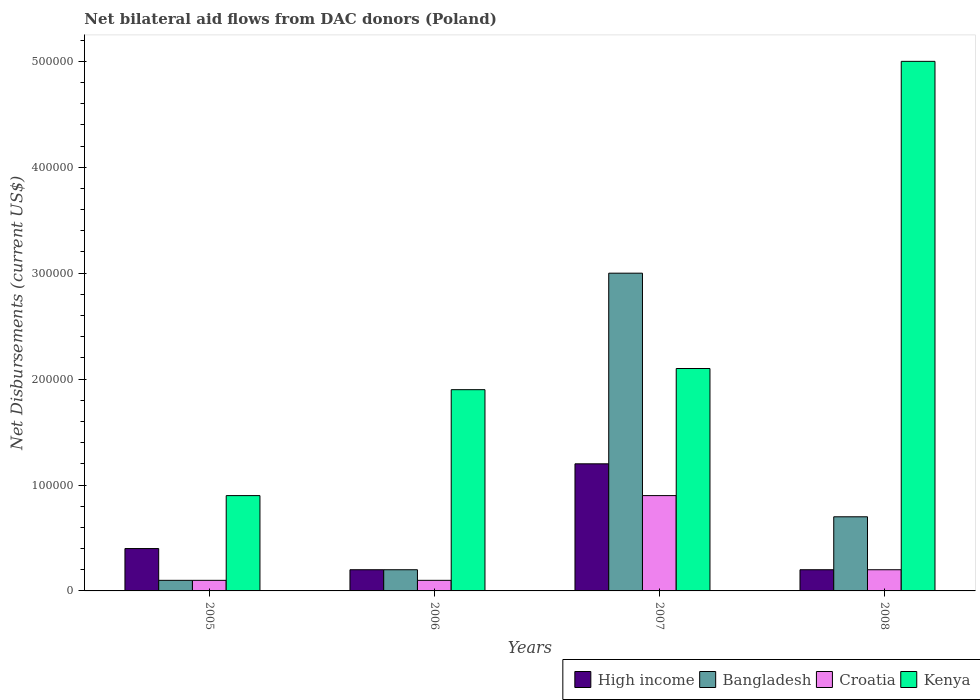How many different coloured bars are there?
Your answer should be compact. 4. How many groups of bars are there?
Your answer should be compact. 4. Are the number of bars on each tick of the X-axis equal?
Provide a short and direct response. Yes. How many bars are there on the 4th tick from the left?
Give a very brief answer. 4. How many bars are there on the 2nd tick from the right?
Make the answer very short. 4. What is the net bilateral aid flows in Croatia in 2008?
Provide a short and direct response. 2.00e+04. Across all years, what is the maximum net bilateral aid flows in Bangladesh?
Provide a short and direct response. 3.00e+05. Across all years, what is the minimum net bilateral aid flows in Bangladesh?
Provide a succinct answer. 10000. What is the total net bilateral aid flows in Bangladesh in the graph?
Your response must be concise. 4.00e+05. What is the difference between the net bilateral aid flows in High income in 2005 and that in 2008?
Provide a short and direct response. 2.00e+04. What is the average net bilateral aid flows in Croatia per year?
Ensure brevity in your answer.  3.25e+04. In the year 2006, what is the difference between the net bilateral aid flows in Kenya and net bilateral aid flows in Croatia?
Offer a terse response. 1.80e+05. What is the ratio of the net bilateral aid flows in Kenya in 2005 to that in 2008?
Offer a terse response. 0.18. What is the difference between the highest and the second highest net bilateral aid flows in High income?
Provide a short and direct response. 8.00e+04. In how many years, is the net bilateral aid flows in Croatia greater than the average net bilateral aid flows in Croatia taken over all years?
Give a very brief answer. 1. Is the sum of the net bilateral aid flows in Croatia in 2006 and 2007 greater than the maximum net bilateral aid flows in Kenya across all years?
Give a very brief answer. No. What does the 2nd bar from the left in 2005 represents?
Ensure brevity in your answer.  Bangladesh. Are all the bars in the graph horizontal?
Give a very brief answer. No. Are the values on the major ticks of Y-axis written in scientific E-notation?
Offer a very short reply. No. How are the legend labels stacked?
Ensure brevity in your answer.  Horizontal. What is the title of the graph?
Provide a succinct answer. Net bilateral aid flows from DAC donors (Poland). What is the label or title of the Y-axis?
Make the answer very short. Net Disbursements (current US$). What is the Net Disbursements (current US$) of Croatia in 2005?
Offer a very short reply. 10000. What is the Net Disbursements (current US$) of Kenya in 2005?
Make the answer very short. 9.00e+04. What is the Net Disbursements (current US$) of Croatia in 2007?
Make the answer very short. 9.00e+04. What is the Net Disbursements (current US$) of Kenya in 2008?
Ensure brevity in your answer.  5.00e+05. Across all years, what is the maximum Net Disbursements (current US$) in High income?
Your answer should be compact. 1.20e+05. Across all years, what is the maximum Net Disbursements (current US$) in Croatia?
Your answer should be very brief. 9.00e+04. Across all years, what is the maximum Net Disbursements (current US$) in Kenya?
Offer a terse response. 5.00e+05. Across all years, what is the minimum Net Disbursements (current US$) in Bangladesh?
Your response must be concise. 10000. Across all years, what is the minimum Net Disbursements (current US$) of Kenya?
Your answer should be very brief. 9.00e+04. What is the total Net Disbursements (current US$) of High income in the graph?
Your answer should be compact. 2.00e+05. What is the total Net Disbursements (current US$) in Kenya in the graph?
Your answer should be very brief. 9.90e+05. What is the difference between the Net Disbursements (current US$) in Bangladesh in 2005 and that in 2006?
Give a very brief answer. -10000. What is the difference between the Net Disbursements (current US$) of Croatia in 2005 and that in 2006?
Keep it short and to the point. 0. What is the difference between the Net Disbursements (current US$) of Kenya in 2005 and that in 2006?
Your response must be concise. -1.00e+05. What is the difference between the Net Disbursements (current US$) of Croatia in 2005 and that in 2007?
Ensure brevity in your answer.  -8.00e+04. What is the difference between the Net Disbursements (current US$) of Bangladesh in 2005 and that in 2008?
Keep it short and to the point. -6.00e+04. What is the difference between the Net Disbursements (current US$) of Kenya in 2005 and that in 2008?
Your answer should be very brief. -4.10e+05. What is the difference between the Net Disbursements (current US$) of Bangladesh in 2006 and that in 2007?
Give a very brief answer. -2.80e+05. What is the difference between the Net Disbursements (current US$) in Croatia in 2006 and that in 2007?
Ensure brevity in your answer.  -8.00e+04. What is the difference between the Net Disbursements (current US$) of Kenya in 2006 and that in 2007?
Keep it short and to the point. -2.00e+04. What is the difference between the Net Disbursements (current US$) of Bangladesh in 2006 and that in 2008?
Give a very brief answer. -5.00e+04. What is the difference between the Net Disbursements (current US$) in Croatia in 2006 and that in 2008?
Provide a succinct answer. -10000. What is the difference between the Net Disbursements (current US$) in Kenya in 2006 and that in 2008?
Ensure brevity in your answer.  -3.10e+05. What is the difference between the Net Disbursements (current US$) in Bangladesh in 2007 and that in 2008?
Your response must be concise. 2.30e+05. What is the difference between the Net Disbursements (current US$) in Croatia in 2007 and that in 2008?
Make the answer very short. 7.00e+04. What is the difference between the Net Disbursements (current US$) of Kenya in 2007 and that in 2008?
Your response must be concise. -2.90e+05. What is the difference between the Net Disbursements (current US$) in High income in 2005 and the Net Disbursements (current US$) in Bangladesh in 2006?
Your response must be concise. 2.00e+04. What is the difference between the Net Disbursements (current US$) of High income in 2005 and the Net Disbursements (current US$) of Croatia in 2006?
Provide a short and direct response. 3.00e+04. What is the difference between the Net Disbursements (current US$) in High income in 2005 and the Net Disbursements (current US$) in Kenya in 2006?
Keep it short and to the point. -1.50e+05. What is the difference between the Net Disbursements (current US$) of Croatia in 2005 and the Net Disbursements (current US$) of Kenya in 2006?
Offer a very short reply. -1.80e+05. What is the difference between the Net Disbursements (current US$) of High income in 2005 and the Net Disbursements (current US$) of Croatia in 2007?
Your response must be concise. -5.00e+04. What is the difference between the Net Disbursements (current US$) of High income in 2005 and the Net Disbursements (current US$) of Kenya in 2007?
Provide a succinct answer. -1.70e+05. What is the difference between the Net Disbursements (current US$) of Bangladesh in 2005 and the Net Disbursements (current US$) of Croatia in 2007?
Provide a succinct answer. -8.00e+04. What is the difference between the Net Disbursements (current US$) of Bangladesh in 2005 and the Net Disbursements (current US$) of Kenya in 2007?
Make the answer very short. -2.00e+05. What is the difference between the Net Disbursements (current US$) of High income in 2005 and the Net Disbursements (current US$) of Bangladesh in 2008?
Provide a short and direct response. -3.00e+04. What is the difference between the Net Disbursements (current US$) in High income in 2005 and the Net Disbursements (current US$) in Kenya in 2008?
Provide a succinct answer. -4.60e+05. What is the difference between the Net Disbursements (current US$) of Bangladesh in 2005 and the Net Disbursements (current US$) of Kenya in 2008?
Offer a terse response. -4.90e+05. What is the difference between the Net Disbursements (current US$) in Croatia in 2005 and the Net Disbursements (current US$) in Kenya in 2008?
Ensure brevity in your answer.  -4.90e+05. What is the difference between the Net Disbursements (current US$) in High income in 2006 and the Net Disbursements (current US$) in Bangladesh in 2007?
Your answer should be very brief. -2.80e+05. What is the difference between the Net Disbursements (current US$) of High income in 2006 and the Net Disbursements (current US$) of Croatia in 2007?
Provide a succinct answer. -7.00e+04. What is the difference between the Net Disbursements (current US$) of Croatia in 2006 and the Net Disbursements (current US$) of Kenya in 2007?
Ensure brevity in your answer.  -2.00e+05. What is the difference between the Net Disbursements (current US$) in High income in 2006 and the Net Disbursements (current US$) in Bangladesh in 2008?
Provide a short and direct response. -5.00e+04. What is the difference between the Net Disbursements (current US$) in High income in 2006 and the Net Disbursements (current US$) in Croatia in 2008?
Offer a very short reply. 0. What is the difference between the Net Disbursements (current US$) in High income in 2006 and the Net Disbursements (current US$) in Kenya in 2008?
Provide a short and direct response. -4.80e+05. What is the difference between the Net Disbursements (current US$) in Bangladesh in 2006 and the Net Disbursements (current US$) in Kenya in 2008?
Give a very brief answer. -4.80e+05. What is the difference between the Net Disbursements (current US$) of Croatia in 2006 and the Net Disbursements (current US$) of Kenya in 2008?
Keep it short and to the point. -4.90e+05. What is the difference between the Net Disbursements (current US$) of High income in 2007 and the Net Disbursements (current US$) of Bangladesh in 2008?
Give a very brief answer. 5.00e+04. What is the difference between the Net Disbursements (current US$) of High income in 2007 and the Net Disbursements (current US$) of Kenya in 2008?
Make the answer very short. -3.80e+05. What is the difference between the Net Disbursements (current US$) of Bangladesh in 2007 and the Net Disbursements (current US$) of Croatia in 2008?
Provide a succinct answer. 2.80e+05. What is the difference between the Net Disbursements (current US$) in Bangladesh in 2007 and the Net Disbursements (current US$) in Kenya in 2008?
Provide a short and direct response. -2.00e+05. What is the difference between the Net Disbursements (current US$) of Croatia in 2007 and the Net Disbursements (current US$) of Kenya in 2008?
Your answer should be very brief. -4.10e+05. What is the average Net Disbursements (current US$) in High income per year?
Offer a very short reply. 5.00e+04. What is the average Net Disbursements (current US$) of Croatia per year?
Your response must be concise. 3.25e+04. What is the average Net Disbursements (current US$) of Kenya per year?
Your answer should be very brief. 2.48e+05. In the year 2005, what is the difference between the Net Disbursements (current US$) of High income and Net Disbursements (current US$) of Bangladesh?
Make the answer very short. 3.00e+04. In the year 2005, what is the difference between the Net Disbursements (current US$) in High income and Net Disbursements (current US$) in Croatia?
Offer a very short reply. 3.00e+04. In the year 2005, what is the difference between the Net Disbursements (current US$) in Bangladesh and Net Disbursements (current US$) in Kenya?
Ensure brevity in your answer.  -8.00e+04. In the year 2005, what is the difference between the Net Disbursements (current US$) in Croatia and Net Disbursements (current US$) in Kenya?
Make the answer very short. -8.00e+04. In the year 2006, what is the difference between the Net Disbursements (current US$) of High income and Net Disbursements (current US$) of Bangladesh?
Provide a short and direct response. 0. In the year 2006, what is the difference between the Net Disbursements (current US$) in High income and Net Disbursements (current US$) in Croatia?
Provide a succinct answer. 10000. In the year 2006, what is the difference between the Net Disbursements (current US$) of High income and Net Disbursements (current US$) of Kenya?
Give a very brief answer. -1.70e+05. In the year 2006, what is the difference between the Net Disbursements (current US$) of Bangladesh and Net Disbursements (current US$) of Croatia?
Provide a short and direct response. 10000. In the year 2006, what is the difference between the Net Disbursements (current US$) in Bangladesh and Net Disbursements (current US$) in Kenya?
Offer a terse response. -1.70e+05. In the year 2007, what is the difference between the Net Disbursements (current US$) in High income and Net Disbursements (current US$) in Bangladesh?
Your response must be concise. -1.80e+05. In the year 2007, what is the difference between the Net Disbursements (current US$) in High income and Net Disbursements (current US$) in Kenya?
Your answer should be very brief. -9.00e+04. In the year 2007, what is the difference between the Net Disbursements (current US$) of Bangladesh and Net Disbursements (current US$) of Kenya?
Provide a short and direct response. 9.00e+04. In the year 2007, what is the difference between the Net Disbursements (current US$) in Croatia and Net Disbursements (current US$) in Kenya?
Make the answer very short. -1.20e+05. In the year 2008, what is the difference between the Net Disbursements (current US$) in High income and Net Disbursements (current US$) in Kenya?
Your answer should be very brief. -4.80e+05. In the year 2008, what is the difference between the Net Disbursements (current US$) in Bangladesh and Net Disbursements (current US$) in Kenya?
Give a very brief answer. -4.30e+05. In the year 2008, what is the difference between the Net Disbursements (current US$) of Croatia and Net Disbursements (current US$) of Kenya?
Ensure brevity in your answer.  -4.80e+05. What is the ratio of the Net Disbursements (current US$) in High income in 2005 to that in 2006?
Provide a succinct answer. 2. What is the ratio of the Net Disbursements (current US$) of Bangladesh in 2005 to that in 2006?
Give a very brief answer. 0.5. What is the ratio of the Net Disbursements (current US$) of Croatia in 2005 to that in 2006?
Offer a terse response. 1. What is the ratio of the Net Disbursements (current US$) in Kenya in 2005 to that in 2006?
Provide a succinct answer. 0.47. What is the ratio of the Net Disbursements (current US$) of High income in 2005 to that in 2007?
Keep it short and to the point. 0.33. What is the ratio of the Net Disbursements (current US$) of Bangladesh in 2005 to that in 2007?
Make the answer very short. 0.03. What is the ratio of the Net Disbursements (current US$) of Kenya in 2005 to that in 2007?
Your answer should be very brief. 0.43. What is the ratio of the Net Disbursements (current US$) of Bangladesh in 2005 to that in 2008?
Keep it short and to the point. 0.14. What is the ratio of the Net Disbursements (current US$) of Kenya in 2005 to that in 2008?
Offer a very short reply. 0.18. What is the ratio of the Net Disbursements (current US$) in Bangladesh in 2006 to that in 2007?
Give a very brief answer. 0.07. What is the ratio of the Net Disbursements (current US$) of Kenya in 2006 to that in 2007?
Ensure brevity in your answer.  0.9. What is the ratio of the Net Disbursements (current US$) in High income in 2006 to that in 2008?
Provide a succinct answer. 1. What is the ratio of the Net Disbursements (current US$) of Bangladesh in 2006 to that in 2008?
Ensure brevity in your answer.  0.29. What is the ratio of the Net Disbursements (current US$) in Croatia in 2006 to that in 2008?
Your answer should be compact. 0.5. What is the ratio of the Net Disbursements (current US$) in Kenya in 2006 to that in 2008?
Provide a short and direct response. 0.38. What is the ratio of the Net Disbursements (current US$) in High income in 2007 to that in 2008?
Your answer should be compact. 6. What is the ratio of the Net Disbursements (current US$) in Bangladesh in 2007 to that in 2008?
Provide a succinct answer. 4.29. What is the ratio of the Net Disbursements (current US$) of Kenya in 2007 to that in 2008?
Offer a very short reply. 0.42. What is the difference between the highest and the second highest Net Disbursements (current US$) of Bangladesh?
Your answer should be very brief. 2.30e+05. What is the difference between the highest and the second highest Net Disbursements (current US$) in Croatia?
Your answer should be very brief. 7.00e+04. What is the difference between the highest and the lowest Net Disbursements (current US$) of Bangladesh?
Your answer should be compact. 2.90e+05. What is the difference between the highest and the lowest Net Disbursements (current US$) in Croatia?
Provide a succinct answer. 8.00e+04. 